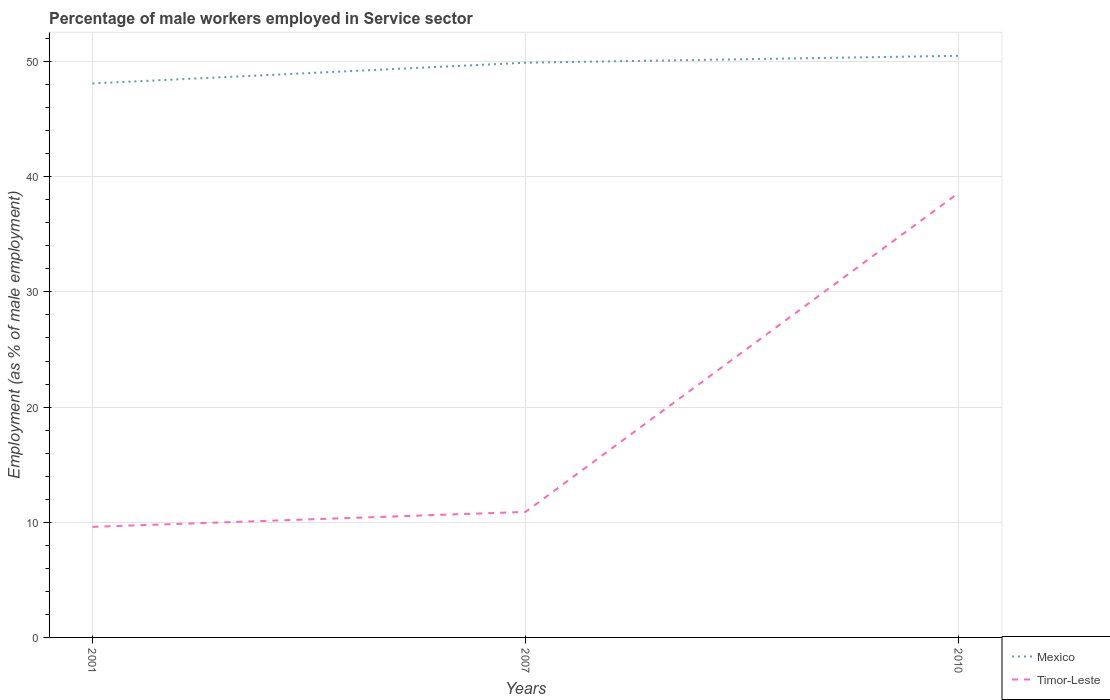How many different coloured lines are there?
Provide a short and direct response. 2. Is the number of lines equal to the number of legend labels?
Your answer should be compact. Yes. Across all years, what is the maximum percentage of male workers employed in Service sector in Timor-Leste?
Provide a succinct answer. 9.6. What is the total percentage of male workers employed in Service sector in Timor-Leste in the graph?
Offer a very short reply. -29. What is the difference between the highest and the second highest percentage of male workers employed in Service sector in Mexico?
Ensure brevity in your answer.  2.4. Is the percentage of male workers employed in Service sector in Mexico strictly greater than the percentage of male workers employed in Service sector in Timor-Leste over the years?
Make the answer very short. No. How many years are there in the graph?
Your answer should be very brief. 3. Does the graph contain grids?
Give a very brief answer. Yes. What is the title of the graph?
Your response must be concise. Percentage of male workers employed in Service sector. What is the label or title of the Y-axis?
Provide a succinct answer. Employment (as % of male employment). What is the Employment (as % of male employment) in Mexico in 2001?
Your response must be concise. 48.1. What is the Employment (as % of male employment) of Timor-Leste in 2001?
Provide a succinct answer. 9.6. What is the Employment (as % of male employment) in Mexico in 2007?
Your answer should be compact. 49.9. What is the Employment (as % of male employment) in Timor-Leste in 2007?
Make the answer very short. 10.9. What is the Employment (as % of male employment) of Mexico in 2010?
Offer a very short reply. 50.5. What is the Employment (as % of male employment) in Timor-Leste in 2010?
Offer a terse response. 38.6. Across all years, what is the maximum Employment (as % of male employment) in Mexico?
Your answer should be compact. 50.5. Across all years, what is the maximum Employment (as % of male employment) in Timor-Leste?
Provide a short and direct response. 38.6. Across all years, what is the minimum Employment (as % of male employment) of Mexico?
Offer a terse response. 48.1. Across all years, what is the minimum Employment (as % of male employment) in Timor-Leste?
Your answer should be compact. 9.6. What is the total Employment (as % of male employment) in Mexico in the graph?
Provide a short and direct response. 148.5. What is the total Employment (as % of male employment) of Timor-Leste in the graph?
Your answer should be very brief. 59.1. What is the difference between the Employment (as % of male employment) of Timor-Leste in 2001 and that in 2010?
Keep it short and to the point. -29. What is the difference between the Employment (as % of male employment) of Mexico in 2007 and that in 2010?
Give a very brief answer. -0.6. What is the difference between the Employment (as % of male employment) in Timor-Leste in 2007 and that in 2010?
Your response must be concise. -27.7. What is the difference between the Employment (as % of male employment) of Mexico in 2001 and the Employment (as % of male employment) of Timor-Leste in 2007?
Ensure brevity in your answer.  37.2. What is the difference between the Employment (as % of male employment) of Mexico in 2001 and the Employment (as % of male employment) of Timor-Leste in 2010?
Offer a terse response. 9.5. What is the difference between the Employment (as % of male employment) in Mexico in 2007 and the Employment (as % of male employment) in Timor-Leste in 2010?
Offer a terse response. 11.3. What is the average Employment (as % of male employment) in Mexico per year?
Your answer should be compact. 49.5. What is the average Employment (as % of male employment) in Timor-Leste per year?
Provide a succinct answer. 19.7. In the year 2001, what is the difference between the Employment (as % of male employment) of Mexico and Employment (as % of male employment) of Timor-Leste?
Your answer should be compact. 38.5. In the year 2007, what is the difference between the Employment (as % of male employment) in Mexico and Employment (as % of male employment) in Timor-Leste?
Give a very brief answer. 39. What is the ratio of the Employment (as % of male employment) of Mexico in 2001 to that in 2007?
Provide a short and direct response. 0.96. What is the ratio of the Employment (as % of male employment) of Timor-Leste in 2001 to that in 2007?
Ensure brevity in your answer.  0.88. What is the ratio of the Employment (as % of male employment) in Mexico in 2001 to that in 2010?
Ensure brevity in your answer.  0.95. What is the ratio of the Employment (as % of male employment) in Timor-Leste in 2001 to that in 2010?
Give a very brief answer. 0.25. What is the ratio of the Employment (as % of male employment) in Timor-Leste in 2007 to that in 2010?
Your response must be concise. 0.28. What is the difference between the highest and the second highest Employment (as % of male employment) of Timor-Leste?
Ensure brevity in your answer.  27.7. What is the difference between the highest and the lowest Employment (as % of male employment) of Mexico?
Your answer should be very brief. 2.4. What is the difference between the highest and the lowest Employment (as % of male employment) in Timor-Leste?
Provide a succinct answer. 29. 